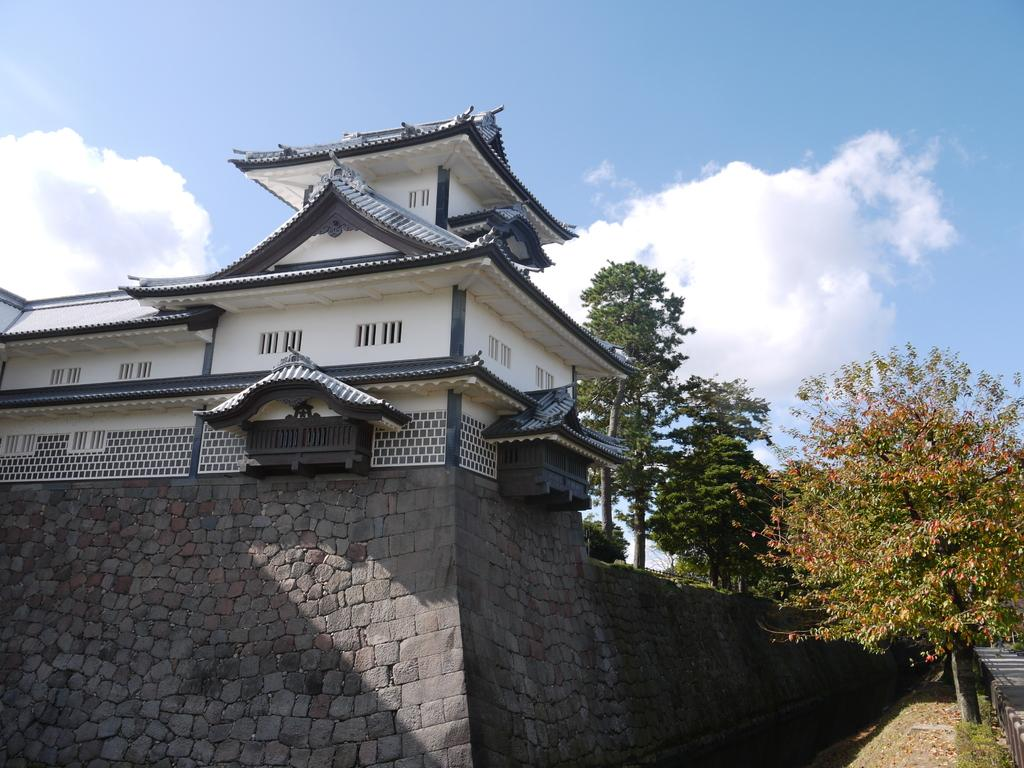What is the main structure in the middle of the image? There is a building in the middle of the image. What type of barrier surrounds the building? There is a stone wall around the building. What type of vegetation is on the right side of the image? There are trees on the right side of the image. What is visible at the top of the image? The sky is visible at the top of the image. Where is the pet hydrant located for the beginner dog in the image? There is no pet, hydrant, or beginner dog present in the image. 